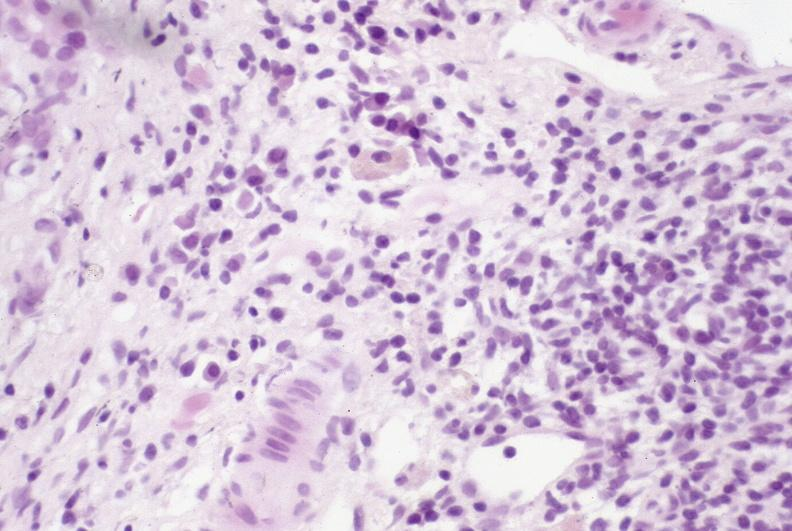s immunoblastic reaction characteristic of viral infection present?
Answer the question using a single word or phrase. No 